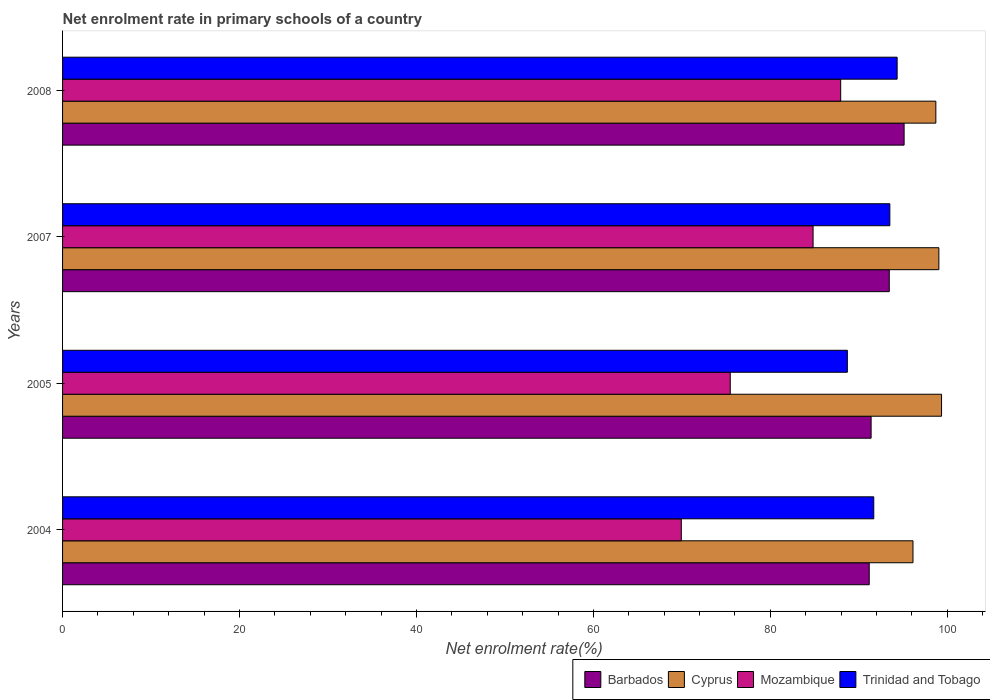How many different coloured bars are there?
Offer a very short reply. 4. How many groups of bars are there?
Offer a terse response. 4. Are the number of bars on each tick of the Y-axis equal?
Your answer should be very brief. Yes. What is the label of the 4th group of bars from the top?
Offer a terse response. 2004. In how many cases, is the number of bars for a given year not equal to the number of legend labels?
Give a very brief answer. 0. What is the net enrolment rate in primary schools in Cyprus in 2004?
Keep it short and to the point. 96.12. Across all years, what is the maximum net enrolment rate in primary schools in Cyprus?
Offer a very short reply. 99.35. Across all years, what is the minimum net enrolment rate in primary schools in Barbados?
Give a very brief answer. 91.17. What is the total net enrolment rate in primary schools in Cyprus in the graph?
Give a very brief answer. 393.21. What is the difference between the net enrolment rate in primary schools in Trinidad and Tobago in 2007 and that in 2008?
Make the answer very short. -0.83. What is the difference between the net enrolment rate in primary schools in Cyprus in 2004 and the net enrolment rate in primary schools in Mozambique in 2005?
Offer a terse response. 20.65. What is the average net enrolment rate in primary schools in Cyprus per year?
Your answer should be compact. 98.3. In the year 2005, what is the difference between the net enrolment rate in primary schools in Trinidad and Tobago and net enrolment rate in primary schools in Cyprus?
Ensure brevity in your answer.  -10.65. In how many years, is the net enrolment rate in primary schools in Trinidad and Tobago greater than 56 %?
Offer a very short reply. 4. What is the ratio of the net enrolment rate in primary schools in Mozambique in 2007 to that in 2008?
Keep it short and to the point. 0.96. Is the difference between the net enrolment rate in primary schools in Trinidad and Tobago in 2004 and 2007 greater than the difference between the net enrolment rate in primary schools in Cyprus in 2004 and 2007?
Keep it short and to the point. Yes. What is the difference between the highest and the second highest net enrolment rate in primary schools in Mozambique?
Provide a succinct answer. 3.12. What is the difference between the highest and the lowest net enrolment rate in primary schools in Mozambique?
Provide a short and direct response. 18.01. In how many years, is the net enrolment rate in primary schools in Cyprus greater than the average net enrolment rate in primary schools in Cyprus taken over all years?
Make the answer very short. 3. What does the 2nd bar from the top in 2007 represents?
Your answer should be very brief. Mozambique. What does the 1st bar from the bottom in 2004 represents?
Give a very brief answer. Barbados. How many bars are there?
Ensure brevity in your answer.  16. Are all the bars in the graph horizontal?
Ensure brevity in your answer.  Yes. How many years are there in the graph?
Your response must be concise. 4. Does the graph contain grids?
Offer a terse response. No. How are the legend labels stacked?
Provide a short and direct response. Horizontal. What is the title of the graph?
Provide a short and direct response. Net enrolment rate in primary schools of a country. Does "Guinea-Bissau" appear as one of the legend labels in the graph?
Your answer should be compact. No. What is the label or title of the X-axis?
Provide a succinct answer. Net enrolment rate(%). What is the Net enrolment rate(%) of Barbados in 2004?
Your answer should be compact. 91.17. What is the Net enrolment rate(%) of Cyprus in 2004?
Give a very brief answer. 96.12. What is the Net enrolment rate(%) of Mozambique in 2004?
Ensure brevity in your answer.  69.93. What is the Net enrolment rate(%) in Trinidad and Tobago in 2004?
Offer a terse response. 91.68. What is the Net enrolment rate(%) of Barbados in 2005?
Offer a terse response. 91.38. What is the Net enrolment rate(%) of Cyprus in 2005?
Offer a terse response. 99.35. What is the Net enrolment rate(%) of Mozambique in 2005?
Provide a succinct answer. 75.46. What is the Net enrolment rate(%) of Trinidad and Tobago in 2005?
Your answer should be very brief. 88.7. What is the Net enrolment rate(%) in Barbados in 2007?
Offer a terse response. 93.44. What is the Net enrolment rate(%) in Cyprus in 2007?
Your answer should be very brief. 99.04. What is the Net enrolment rate(%) of Mozambique in 2007?
Your response must be concise. 84.83. What is the Net enrolment rate(%) of Trinidad and Tobago in 2007?
Keep it short and to the point. 93.5. What is the Net enrolment rate(%) in Barbados in 2008?
Provide a short and direct response. 95.12. What is the Net enrolment rate(%) of Cyprus in 2008?
Offer a very short reply. 98.7. What is the Net enrolment rate(%) in Mozambique in 2008?
Offer a very short reply. 87.95. What is the Net enrolment rate(%) of Trinidad and Tobago in 2008?
Your answer should be compact. 94.33. Across all years, what is the maximum Net enrolment rate(%) of Barbados?
Keep it short and to the point. 95.12. Across all years, what is the maximum Net enrolment rate(%) in Cyprus?
Ensure brevity in your answer.  99.35. Across all years, what is the maximum Net enrolment rate(%) in Mozambique?
Offer a very short reply. 87.95. Across all years, what is the maximum Net enrolment rate(%) of Trinidad and Tobago?
Your answer should be compact. 94.33. Across all years, what is the minimum Net enrolment rate(%) of Barbados?
Offer a very short reply. 91.17. Across all years, what is the minimum Net enrolment rate(%) of Cyprus?
Your answer should be very brief. 96.12. Across all years, what is the minimum Net enrolment rate(%) of Mozambique?
Provide a succinct answer. 69.93. Across all years, what is the minimum Net enrolment rate(%) of Trinidad and Tobago?
Make the answer very short. 88.7. What is the total Net enrolment rate(%) in Barbados in the graph?
Make the answer very short. 371.11. What is the total Net enrolment rate(%) in Cyprus in the graph?
Ensure brevity in your answer.  393.21. What is the total Net enrolment rate(%) of Mozambique in the graph?
Offer a very short reply. 318.17. What is the total Net enrolment rate(%) in Trinidad and Tobago in the graph?
Your response must be concise. 368.22. What is the difference between the Net enrolment rate(%) in Barbados in 2004 and that in 2005?
Your answer should be compact. -0.21. What is the difference between the Net enrolment rate(%) in Cyprus in 2004 and that in 2005?
Provide a succinct answer. -3.23. What is the difference between the Net enrolment rate(%) of Mozambique in 2004 and that in 2005?
Your response must be concise. -5.53. What is the difference between the Net enrolment rate(%) in Trinidad and Tobago in 2004 and that in 2005?
Offer a terse response. 2.98. What is the difference between the Net enrolment rate(%) of Barbados in 2004 and that in 2007?
Give a very brief answer. -2.27. What is the difference between the Net enrolment rate(%) in Cyprus in 2004 and that in 2007?
Your answer should be very brief. -2.93. What is the difference between the Net enrolment rate(%) of Mozambique in 2004 and that in 2007?
Your answer should be very brief. -14.89. What is the difference between the Net enrolment rate(%) in Trinidad and Tobago in 2004 and that in 2007?
Provide a succinct answer. -1.82. What is the difference between the Net enrolment rate(%) of Barbados in 2004 and that in 2008?
Ensure brevity in your answer.  -3.94. What is the difference between the Net enrolment rate(%) of Cyprus in 2004 and that in 2008?
Ensure brevity in your answer.  -2.58. What is the difference between the Net enrolment rate(%) in Mozambique in 2004 and that in 2008?
Offer a terse response. -18.01. What is the difference between the Net enrolment rate(%) in Trinidad and Tobago in 2004 and that in 2008?
Make the answer very short. -2.64. What is the difference between the Net enrolment rate(%) of Barbados in 2005 and that in 2007?
Offer a terse response. -2.05. What is the difference between the Net enrolment rate(%) of Cyprus in 2005 and that in 2007?
Ensure brevity in your answer.  0.3. What is the difference between the Net enrolment rate(%) in Mozambique in 2005 and that in 2007?
Make the answer very short. -9.36. What is the difference between the Net enrolment rate(%) in Trinidad and Tobago in 2005 and that in 2007?
Give a very brief answer. -4.8. What is the difference between the Net enrolment rate(%) in Barbados in 2005 and that in 2008?
Make the answer very short. -3.73. What is the difference between the Net enrolment rate(%) in Cyprus in 2005 and that in 2008?
Your response must be concise. 0.64. What is the difference between the Net enrolment rate(%) of Mozambique in 2005 and that in 2008?
Make the answer very short. -12.48. What is the difference between the Net enrolment rate(%) in Trinidad and Tobago in 2005 and that in 2008?
Your answer should be compact. -5.63. What is the difference between the Net enrolment rate(%) of Barbados in 2007 and that in 2008?
Offer a terse response. -1.68. What is the difference between the Net enrolment rate(%) of Cyprus in 2007 and that in 2008?
Provide a short and direct response. 0.34. What is the difference between the Net enrolment rate(%) of Mozambique in 2007 and that in 2008?
Keep it short and to the point. -3.12. What is the difference between the Net enrolment rate(%) of Trinidad and Tobago in 2007 and that in 2008?
Your answer should be compact. -0.83. What is the difference between the Net enrolment rate(%) in Barbados in 2004 and the Net enrolment rate(%) in Cyprus in 2005?
Ensure brevity in your answer.  -8.17. What is the difference between the Net enrolment rate(%) in Barbados in 2004 and the Net enrolment rate(%) in Mozambique in 2005?
Offer a terse response. 15.71. What is the difference between the Net enrolment rate(%) of Barbados in 2004 and the Net enrolment rate(%) of Trinidad and Tobago in 2005?
Offer a terse response. 2.47. What is the difference between the Net enrolment rate(%) in Cyprus in 2004 and the Net enrolment rate(%) in Mozambique in 2005?
Ensure brevity in your answer.  20.65. What is the difference between the Net enrolment rate(%) in Cyprus in 2004 and the Net enrolment rate(%) in Trinidad and Tobago in 2005?
Ensure brevity in your answer.  7.42. What is the difference between the Net enrolment rate(%) of Mozambique in 2004 and the Net enrolment rate(%) of Trinidad and Tobago in 2005?
Give a very brief answer. -18.77. What is the difference between the Net enrolment rate(%) in Barbados in 2004 and the Net enrolment rate(%) in Cyprus in 2007?
Your answer should be compact. -7.87. What is the difference between the Net enrolment rate(%) of Barbados in 2004 and the Net enrolment rate(%) of Mozambique in 2007?
Offer a terse response. 6.35. What is the difference between the Net enrolment rate(%) in Barbados in 2004 and the Net enrolment rate(%) in Trinidad and Tobago in 2007?
Give a very brief answer. -2.33. What is the difference between the Net enrolment rate(%) of Cyprus in 2004 and the Net enrolment rate(%) of Mozambique in 2007?
Give a very brief answer. 11.29. What is the difference between the Net enrolment rate(%) of Cyprus in 2004 and the Net enrolment rate(%) of Trinidad and Tobago in 2007?
Keep it short and to the point. 2.61. What is the difference between the Net enrolment rate(%) of Mozambique in 2004 and the Net enrolment rate(%) of Trinidad and Tobago in 2007?
Offer a very short reply. -23.57. What is the difference between the Net enrolment rate(%) of Barbados in 2004 and the Net enrolment rate(%) of Cyprus in 2008?
Provide a succinct answer. -7.53. What is the difference between the Net enrolment rate(%) of Barbados in 2004 and the Net enrolment rate(%) of Mozambique in 2008?
Offer a terse response. 3.23. What is the difference between the Net enrolment rate(%) of Barbados in 2004 and the Net enrolment rate(%) of Trinidad and Tobago in 2008?
Provide a short and direct response. -3.15. What is the difference between the Net enrolment rate(%) in Cyprus in 2004 and the Net enrolment rate(%) in Mozambique in 2008?
Your answer should be compact. 8.17. What is the difference between the Net enrolment rate(%) in Cyprus in 2004 and the Net enrolment rate(%) in Trinidad and Tobago in 2008?
Provide a succinct answer. 1.79. What is the difference between the Net enrolment rate(%) in Mozambique in 2004 and the Net enrolment rate(%) in Trinidad and Tobago in 2008?
Keep it short and to the point. -24.39. What is the difference between the Net enrolment rate(%) of Barbados in 2005 and the Net enrolment rate(%) of Cyprus in 2007?
Offer a terse response. -7.66. What is the difference between the Net enrolment rate(%) of Barbados in 2005 and the Net enrolment rate(%) of Mozambique in 2007?
Provide a short and direct response. 6.56. What is the difference between the Net enrolment rate(%) in Barbados in 2005 and the Net enrolment rate(%) in Trinidad and Tobago in 2007?
Give a very brief answer. -2.12. What is the difference between the Net enrolment rate(%) in Cyprus in 2005 and the Net enrolment rate(%) in Mozambique in 2007?
Make the answer very short. 14.52. What is the difference between the Net enrolment rate(%) in Cyprus in 2005 and the Net enrolment rate(%) in Trinidad and Tobago in 2007?
Provide a short and direct response. 5.84. What is the difference between the Net enrolment rate(%) in Mozambique in 2005 and the Net enrolment rate(%) in Trinidad and Tobago in 2007?
Offer a very short reply. -18.04. What is the difference between the Net enrolment rate(%) in Barbados in 2005 and the Net enrolment rate(%) in Cyprus in 2008?
Provide a succinct answer. -7.32. What is the difference between the Net enrolment rate(%) of Barbados in 2005 and the Net enrolment rate(%) of Mozambique in 2008?
Your answer should be compact. 3.44. What is the difference between the Net enrolment rate(%) of Barbados in 2005 and the Net enrolment rate(%) of Trinidad and Tobago in 2008?
Offer a very short reply. -2.94. What is the difference between the Net enrolment rate(%) of Cyprus in 2005 and the Net enrolment rate(%) of Mozambique in 2008?
Your answer should be very brief. 11.4. What is the difference between the Net enrolment rate(%) in Cyprus in 2005 and the Net enrolment rate(%) in Trinidad and Tobago in 2008?
Keep it short and to the point. 5.02. What is the difference between the Net enrolment rate(%) of Mozambique in 2005 and the Net enrolment rate(%) of Trinidad and Tobago in 2008?
Provide a short and direct response. -18.86. What is the difference between the Net enrolment rate(%) in Barbados in 2007 and the Net enrolment rate(%) in Cyprus in 2008?
Offer a very short reply. -5.26. What is the difference between the Net enrolment rate(%) of Barbados in 2007 and the Net enrolment rate(%) of Mozambique in 2008?
Offer a very short reply. 5.49. What is the difference between the Net enrolment rate(%) in Barbados in 2007 and the Net enrolment rate(%) in Trinidad and Tobago in 2008?
Give a very brief answer. -0.89. What is the difference between the Net enrolment rate(%) in Cyprus in 2007 and the Net enrolment rate(%) in Mozambique in 2008?
Keep it short and to the point. 11.1. What is the difference between the Net enrolment rate(%) of Cyprus in 2007 and the Net enrolment rate(%) of Trinidad and Tobago in 2008?
Your answer should be very brief. 4.71. What is the difference between the Net enrolment rate(%) of Mozambique in 2007 and the Net enrolment rate(%) of Trinidad and Tobago in 2008?
Make the answer very short. -9.5. What is the average Net enrolment rate(%) in Barbados per year?
Your response must be concise. 92.78. What is the average Net enrolment rate(%) of Cyprus per year?
Offer a very short reply. 98.3. What is the average Net enrolment rate(%) of Mozambique per year?
Provide a short and direct response. 79.54. What is the average Net enrolment rate(%) of Trinidad and Tobago per year?
Make the answer very short. 92.05. In the year 2004, what is the difference between the Net enrolment rate(%) of Barbados and Net enrolment rate(%) of Cyprus?
Offer a terse response. -4.94. In the year 2004, what is the difference between the Net enrolment rate(%) in Barbados and Net enrolment rate(%) in Mozambique?
Offer a terse response. 21.24. In the year 2004, what is the difference between the Net enrolment rate(%) in Barbados and Net enrolment rate(%) in Trinidad and Tobago?
Provide a succinct answer. -0.51. In the year 2004, what is the difference between the Net enrolment rate(%) of Cyprus and Net enrolment rate(%) of Mozambique?
Make the answer very short. 26.18. In the year 2004, what is the difference between the Net enrolment rate(%) of Cyprus and Net enrolment rate(%) of Trinidad and Tobago?
Give a very brief answer. 4.43. In the year 2004, what is the difference between the Net enrolment rate(%) of Mozambique and Net enrolment rate(%) of Trinidad and Tobago?
Give a very brief answer. -21.75. In the year 2005, what is the difference between the Net enrolment rate(%) of Barbados and Net enrolment rate(%) of Cyprus?
Make the answer very short. -7.96. In the year 2005, what is the difference between the Net enrolment rate(%) of Barbados and Net enrolment rate(%) of Mozambique?
Offer a very short reply. 15.92. In the year 2005, what is the difference between the Net enrolment rate(%) in Barbados and Net enrolment rate(%) in Trinidad and Tobago?
Make the answer very short. 2.68. In the year 2005, what is the difference between the Net enrolment rate(%) in Cyprus and Net enrolment rate(%) in Mozambique?
Keep it short and to the point. 23.88. In the year 2005, what is the difference between the Net enrolment rate(%) of Cyprus and Net enrolment rate(%) of Trinidad and Tobago?
Ensure brevity in your answer.  10.65. In the year 2005, what is the difference between the Net enrolment rate(%) of Mozambique and Net enrolment rate(%) of Trinidad and Tobago?
Your response must be concise. -13.24. In the year 2007, what is the difference between the Net enrolment rate(%) of Barbados and Net enrolment rate(%) of Cyprus?
Your answer should be very brief. -5.6. In the year 2007, what is the difference between the Net enrolment rate(%) of Barbados and Net enrolment rate(%) of Mozambique?
Keep it short and to the point. 8.61. In the year 2007, what is the difference between the Net enrolment rate(%) in Barbados and Net enrolment rate(%) in Trinidad and Tobago?
Provide a succinct answer. -0.06. In the year 2007, what is the difference between the Net enrolment rate(%) of Cyprus and Net enrolment rate(%) of Mozambique?
Provide a short and direct response. 14.22. In the year 2007, what is the difference between the Net enrolment rate(%) of Cyprus and Net enrolment rate(%) of Trinidad and Tobago?
Offer a terse response. 5.54. In the year 2007, what is the difference between the Net enrolment rate(%) of Mozambique and Net enrolment rate(%) of Trinidad and Tobago?
Keep it short and to the point. -8.68. In the year 2008, what is the difference between the Net enrolment rate(%) in Barbados and Net enrolment rate(%) in Cyprus?
Make the answer very short. -3.59. In the year 2008, what is the difference between the Net enrolment rate(%) in Barbados and Net enrolment rate(%) in Mozambique?
Offer a very short reply. 7.17. In the year 2008, what is the difference between the Net enrolment rate(%) in Barbados and Net enrolment rate(%) in Trinidad and Tobago?
Provide a succinct answer. 0.79. In the year 2008, what is the difference between the Net enrolment rate(%) of Cyprus and Net enrolment rate(%) of Mozambique?
Provide a succinct answer. 10.76. In the year 2008, what is the difference between the Net enrolment rate(%) in Cyprus and Net enrolment rate(%) in Trinidad and Tobago?
Provide a succinct answer. 4.37. In the year 2008, what is the difference between the Net enrolment rate(%) in Mozambique and Net enrolment rate(%) in Trinidad and Tobago?
Provide a succinct answer. -6.38. What is the ratio of the Net enrolment rate(%) of Cyprus in 2004 to that in 2005?
Offer a very short reply. 0.97. What is the ratio of the Net enrolment rate(%) in Mozambique in 2004 to that in 2005?
Your answer should be compact. 0.93. What is the ratio of the Net enrolment rate(%) in Trinidad and Tobago in 2004 to that in 2005?
Give a very brief answer. 1.03. What is the ratio of the Net enrolment rate(%) in Barbados in 2004 to that in 2007?
Make the answer very short. 0.98. What is the ratio of the Net enrolment rate(%) in Cyprus in 2004 to that in 2007?
Provide a short and direct response. 0.97. What is the ratio of the Net enrolment rate(%) in Mozambique in 2004 to that in 2007?
Provide a short and direct response. 0.82. What is the ratio of the Net enrolment rate(%) of Trinidad and Tobago in 2004 to that in 2007?
Offer a very short reply. 0.98. What is the ratio of the Net enrolment rate(%) in Barbados in 2004 to that in 2008?
Offer a very short reply. 0.96. What is the ratio of the Net enrolment rate(%) of Cyprus in 2004 to that in 2008?
Provide a succinct answer. 0.97. What is the ratio of the Net enrolment rate(%) in Mozambique in 2004 to that in 2008?
Keep it short and to the point. 0.8. What is the ratio of the Net enrolment rate(%) of Trinidad and Tobago in 2004 to that in 2008?
Make the answer very short. 0.97. What is the ratio of the Net enrolment rate(%) in Mozambique in 2005 to that in 2007?
Provide a succinct answer. 0.89. What is the ratio of the Net enrolment rate(%) in Trinidad and Tobago in 2005 to that in 2007?
Your answer should be compact. 0.95. What is the ratio of the Net enrolment rate(%) of Barbados in 2005 to that in 2008?
Keep it short and to the point. 0.96. What is the ratio of the Net enrolment rate(%) of Mozambique in 2005 to that in 2008?
Provide a short and direct response. 0.86. What is the ratio of the Net enrolment rate(%) in Trinidad and Tobago in 2005 to that in 2008?
Offer a very short reply. 0.94. What is the ratio of the Net enrolment rate(%) in Barbados in 2007 to that in 2008?
Your answer should be very brief. 0.98. What is the ratio of the Net enrolment rate(%) in Mozambique in 2007 to that in 2008?
Keep it short and to the point. 0.96. What is the difference between the highest and the second highest Net enrolment rate(%) in Barbados?
Keep it short and to the point. 1.68. What is the difference between the highest and the second highest Net enrolment rate(%) of Cyprus?
Make the answer very short. 0.3. What is the difference between the highest and the second highest Net enrolment rate(%) in Mozambique?
Keep it short and to the point. 3.12. What is the difference between the highest and the second highest Net enrolment rate(%) in Trinidad and Tobago?
Your response must be concise. 0.83. What is the difference between the highest and the lowest Net enrolment rate(%) of Barbados?
Provide a succinct answer. 3.94. What is the difference between the highest and the lowest Net enrolment rate(%) of Cyprus?
Your answer should be compact. 3.23. What is the difference between the highest and the lowest Net enrolment rate(%) of Mozambique?
Make the answer very short. 18.01. What is the difference between the highest and the lowest Net enrolment rate(%) of Trinidad and Tobago?
Offer a terse response. 5.63. 